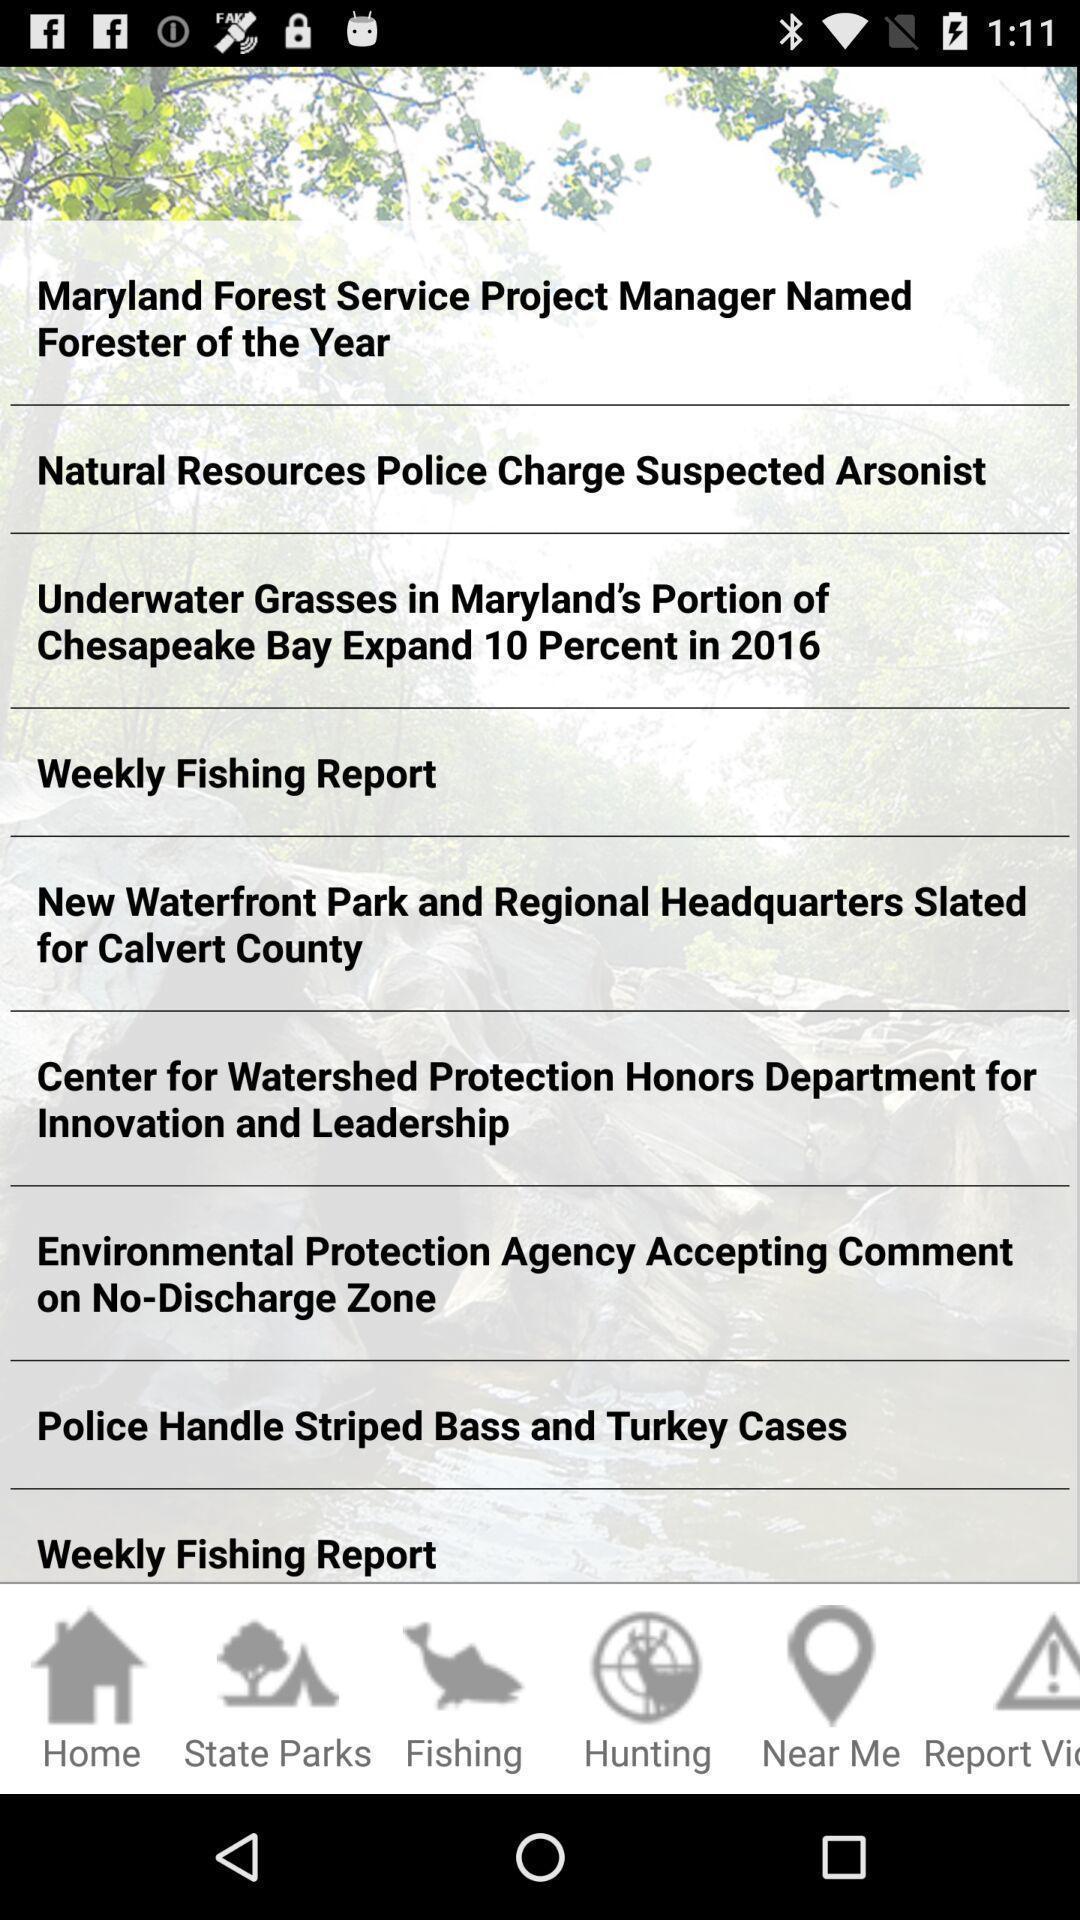Describe the visual elements of this screenshot. Screen shows list of options in a forest app. 